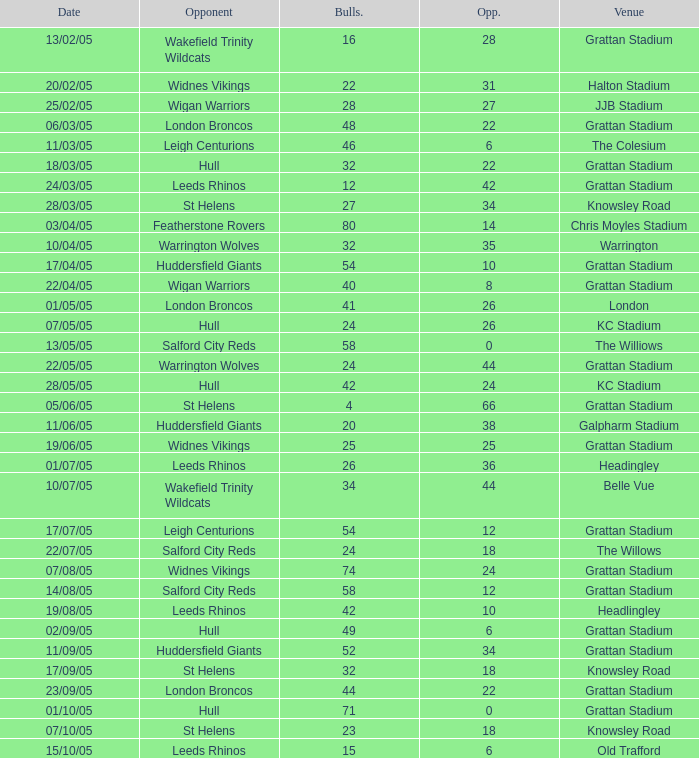What was the complete sum for the bulls while they were at old trafford? 1.0. 